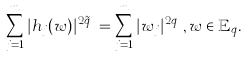<formula> <loc_0><loc_0><loc_500><loc_500>\sum _ { j = 1 } ^ { m } | h _ { j } ( w ) | ^ { 2 \tilde { q } _ { j } } = \sum _ { j = 1 } ^ { m } | w _ { j } | ^ { 2 q _ { j } } , w \in \mathbb { E } _ { q } .</formula> 